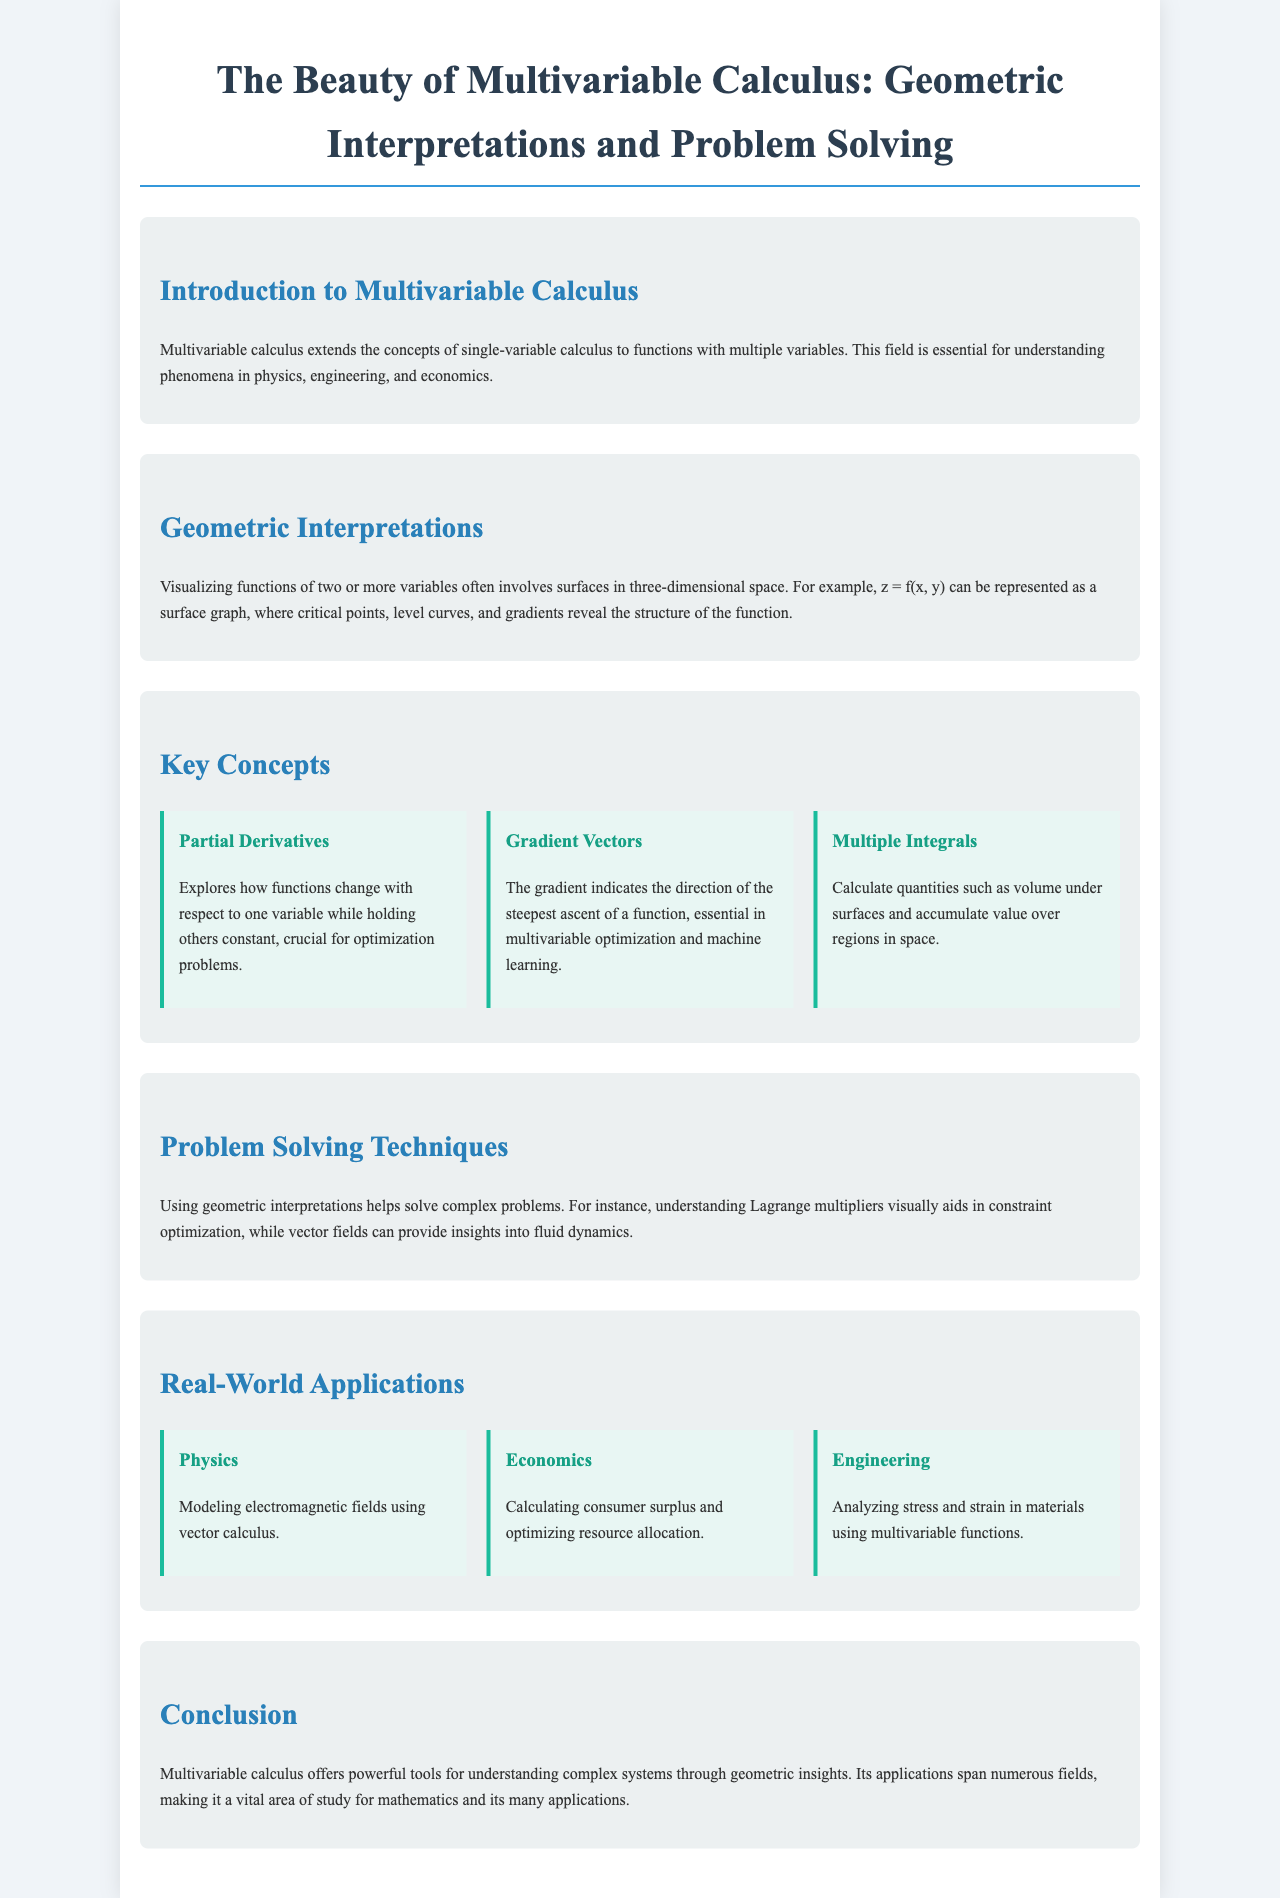What is the main focus of multivariable calculus? The document states that multivariable calculus extends the concepts of single-variable calculus to functions with multiple variables, essential for understanding phenomena in physics, engineering, and economics.
Answer: functions with multiple variables What does the gradient indicate? The document explains that the gradient indicates the direction of the steepest ascent of a function, important in optimization.
Answer: steepest ascent Name one key concept discussed in the brochure. The brochure lists several key concepts, including partial derivatives, gradient vectors, and multiple integrals.
Answer: partial derivatives What is an application of multivariable calculus in physics? The document mentions that one application is modeling electromagnetic fields using vector calculus.
Answer: modeling electromagnetic fields What problem-solving technique is highlighted in the document? The text explains that understanding Lagrange multipliers visually aids in constraint optimization, which is a technique for solving complex problems.
Answer: Lagrange multipliers What kind of functions does multiple integrals calculate? The document states that multiple integrals calculate quantities such as volume under surfaces and accumulate value over regions in space.
Answer: volume under surfaces Which field utilizes multivariable calculus for analyzing stress in materials? According to the document, engineering uses multivariable calculus for analyzing stress and strain in materials.
Answer: engineering What is the tone of the brochure? The brochure presents a positive and informative exploration of multivariable calculus emphasizing its beauty and applications.
Answer: positive and informative 